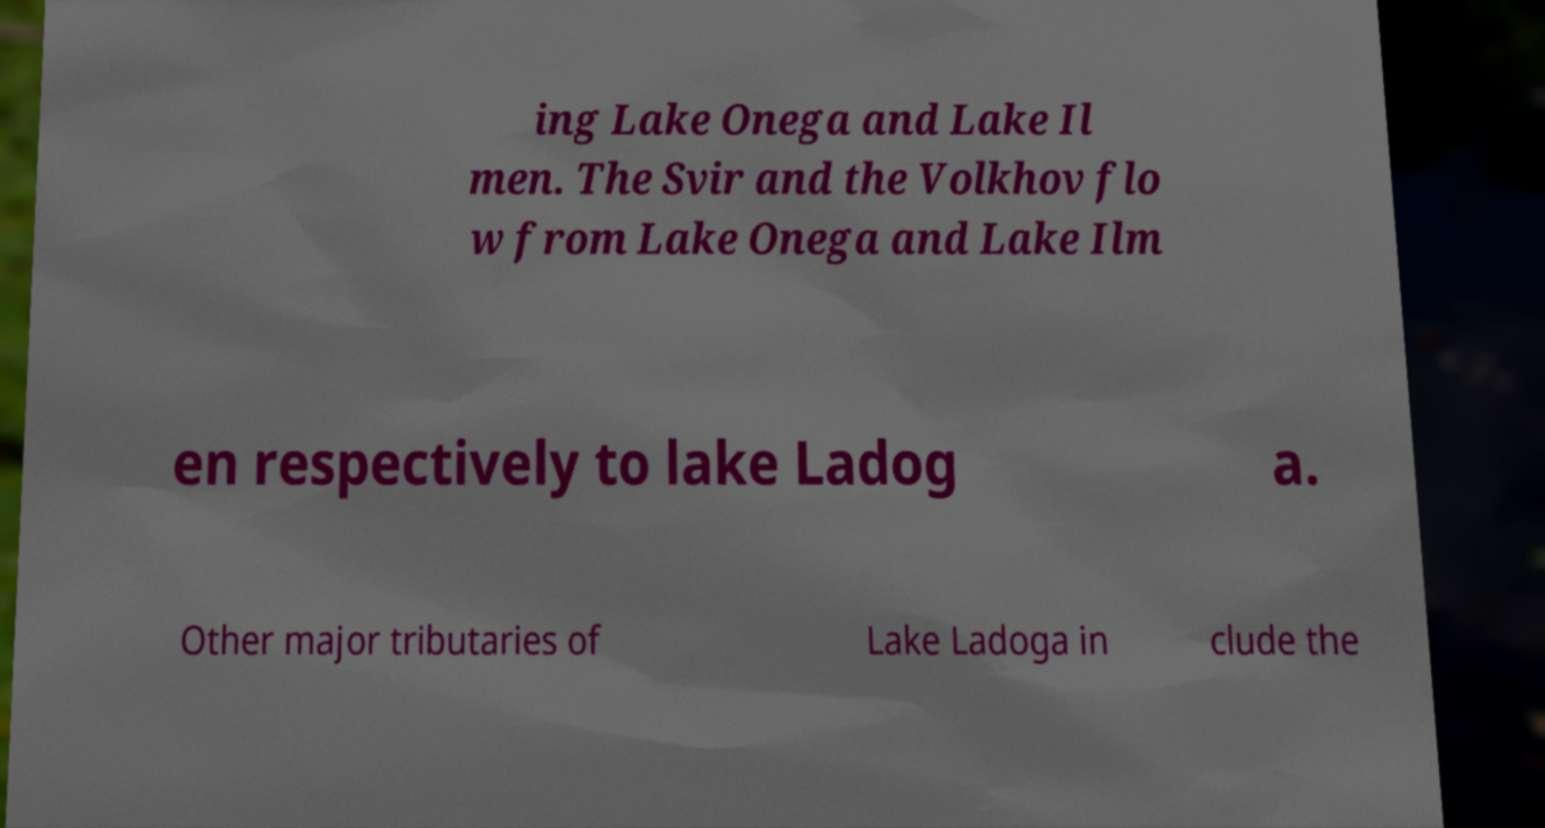There's text embedded in this image that I need extracted. Can you transcribe it verbatim? ing Lake Onega and Lake Il men. The Svir and the Volkhov flo w from Lake Onega and Lake Ilm en respectively to lake Ladog a. Other major tributaries of Lake Ladoga in clude the 